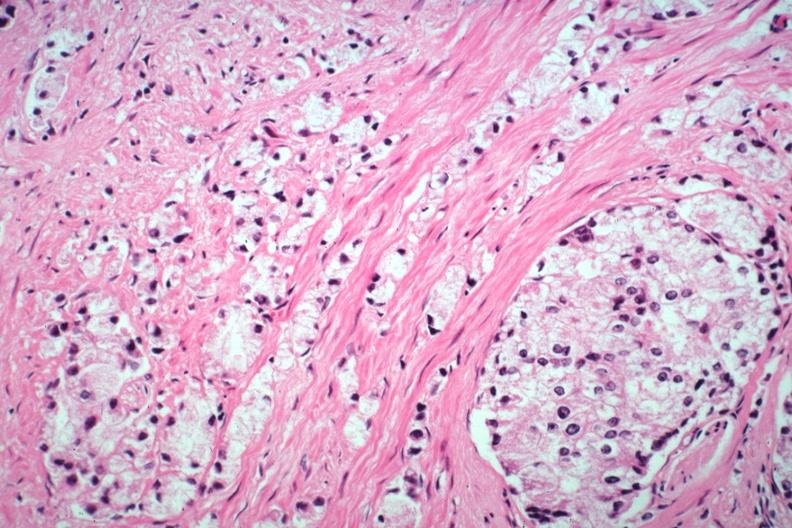what does this image show?
Answer the question using a single word or phrase. Typical infiltrating lesion 